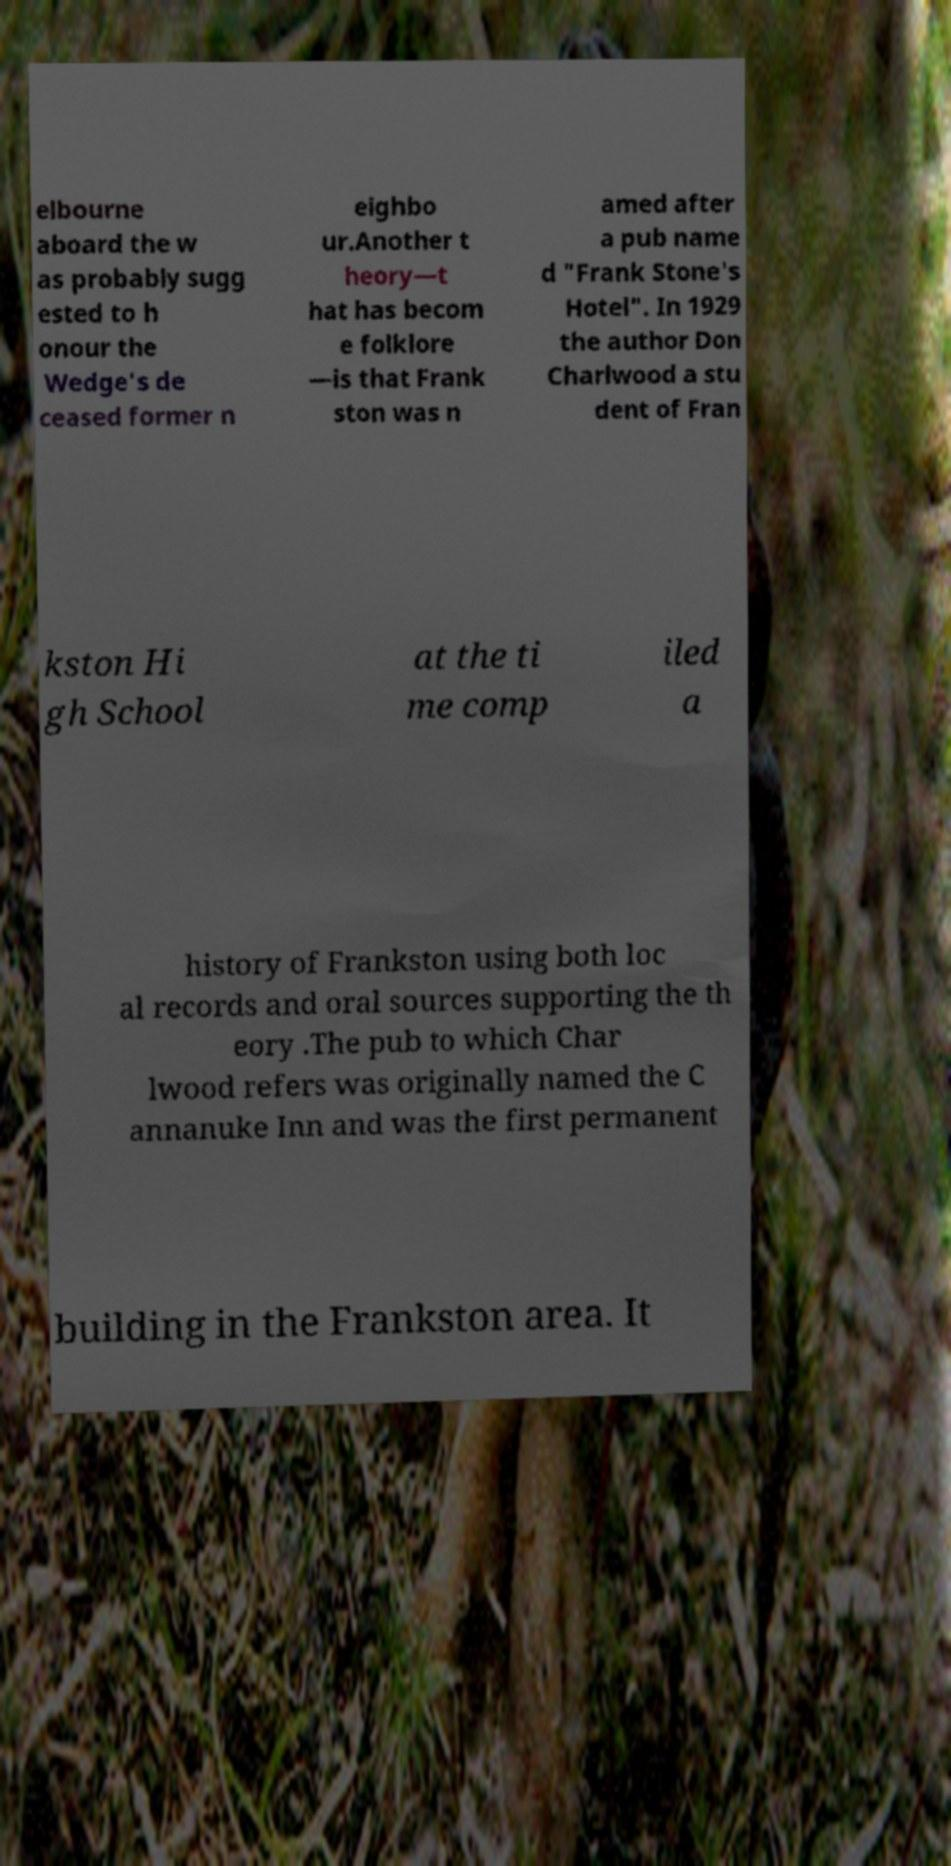I need the written content from this picture converted into text. Can you do that? elbourne aboard the w as probably sugg ested to h onour the Wedge's de ceased former n eighbo ur.Another t heory—t hat has becom e folklore —is that Frank ston was n amed after a pub name d "Frank Stone's Hotel". In 1929 the author Don Charlwood a stu dent of Fran kston Hi gh School at the ti me comp iled a history of Frankston using both loc al records and oral sources supporting the th eory .The pub to which Char lwood refers was originally named the C annanuke Inn and was the first permanent building in the Frankston area. It 